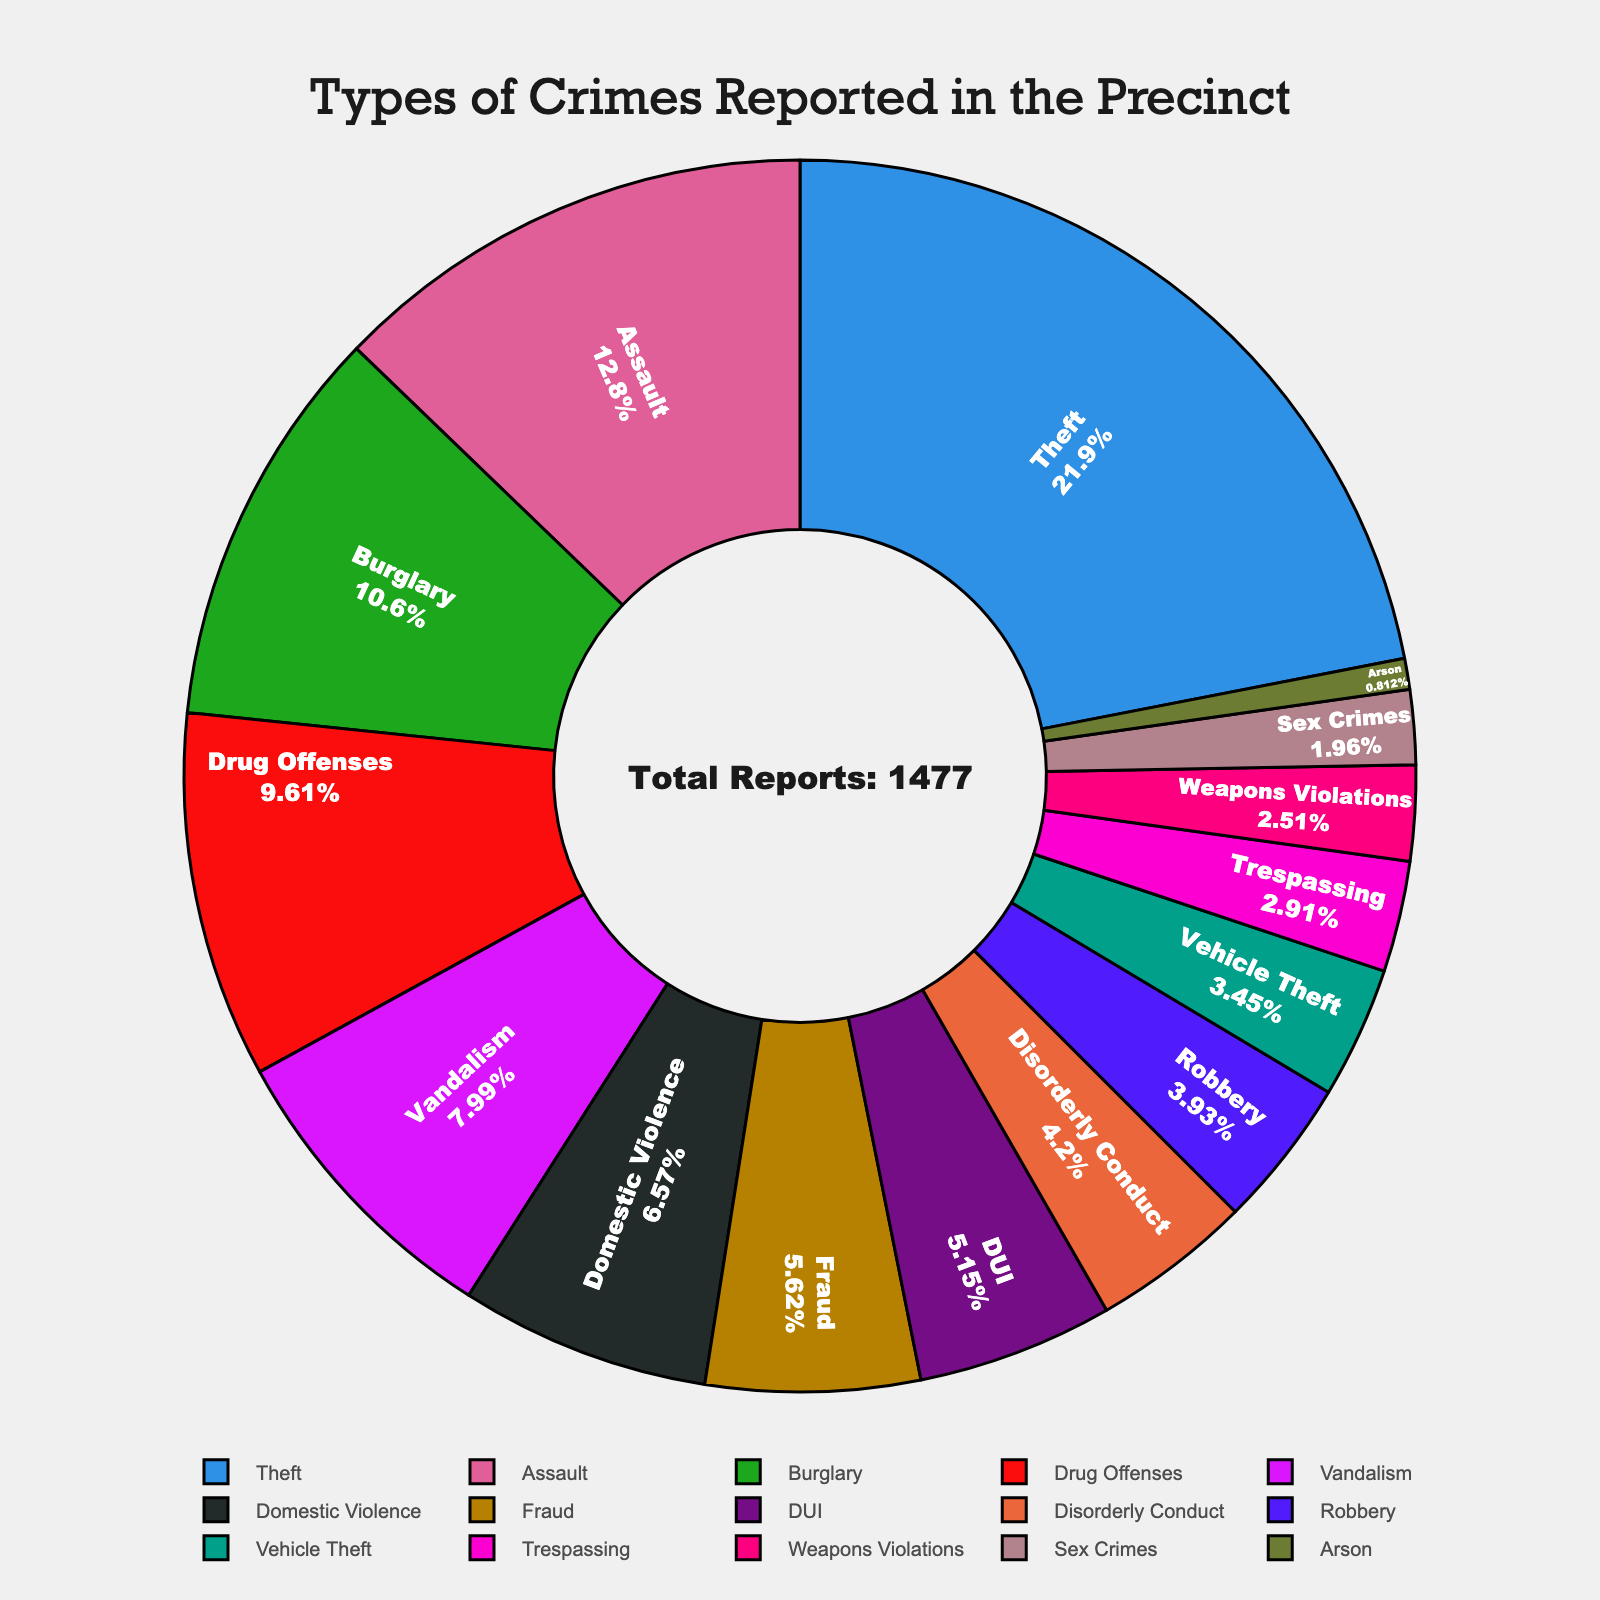How many reports are from Theft and Burglary combined? Sum the reports from both categories: Theft (324) + Burglary (156) = 480.
Answer: 480 Which crime category has the least number of reports? Identify the category with the smallest number. Arson has the least with 12 reports.
Answer: Arson Do Theft and Assault reports combined exceed the total number of reports from the other categories? Sum Theft (324) and Assault (189) = 513. Sum the remaining categories: 142 + 118 + 97 + 83 + 76 + 62 + 58 + 51 + 43 + 37 + 29 + 12 = 808. Theft and Assault combined (513) do not exceed other categories (808).
Answer: No Which crime category has a higher number of reports: Vandalism or Fraud? Compare numbers: Vandalism (118) is higher than Fraud (83).
Answer: Vandalism What percentage of total reports are for Domestic Violence? Total reports = 1497. Domestic Violence reports = 97. Percentage = (97/1497) * 100 ≈ 6.48%.
Answer: 6.48% Are the reports for DUI and Disorderly Conduct nearly equal? Compare numbers: DUI (76) and Disorderly Conduct (62). They are not nearly equal.
Answer: No What is the difference between the number of reports of Vehicle Theft and Robbery? Calculate difference: Vehicle Theft (51) - Robbery (58) = -7.
Answer: 7 Which crime categories have more than 100 reports? Identify categories with reports > 100: Theft (324), Assault (189), Burglary (156), Drug Offenses (142), Vandalism (118).
Answer: 5 categories How many more reports are there for Assault compared to Domestic Violence? Calculate difference: Assault (189) - Domestic Violence (97) = 92.
Answer: 92 What is the combined total of reports for all categories except the top three? Top three categories: Theft (324), Assault (189), Burglary (156). Remaining reports: 1497 - (324 + 189 + 156) = 828.
Answer: 828 